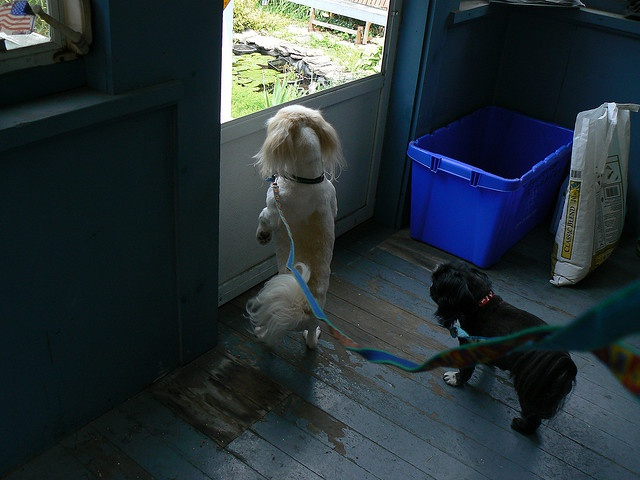Describe the objects in this image and their specific colors. I can see dog in olive, black, gray, and darkgray tones and dog in olive, black, gray, navy, and blue tones in this image. 